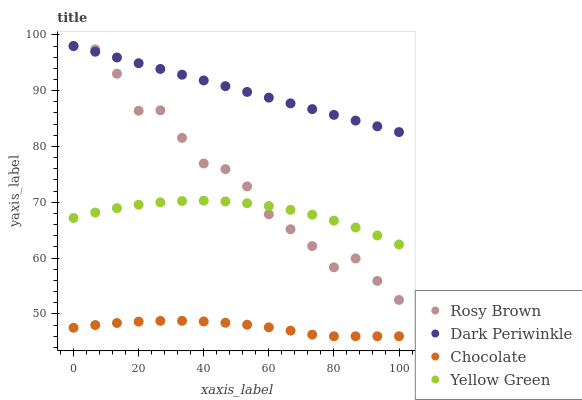Does Chocolate have the minimum area under the curve?
Answer yes or no. Yes. Does Dark Periwinkle have the maximum area under the curve?
Answer yes or no. Yes. Does Rosy Brown have the minimum area under the curve?
Answer yes or no. No. Does Rosy Brown have the maximum area under the curve?
Answer yes or no. No. Is Dark Periwinkle the smoothest?
Answer yes or no. Yes. Is Rosy Brown the roughest?
Answer yes or no. Yes. Is Rosy Brown the smoothest?
Answer yes or no. No. Is Dark Periwinkle the roughest?
Answer yes or no. No. Does Chocolate have the lowest value?
Answer yes or no. Yes. Does Rosy Brown have the lowest value?
Answer yes or no. No. Does Dark Periwinkle have the highest value?
Answer yes or no. Yes. Does Chocolate have the highest value?
Answer yes or no. No. Is Chocolate less than Yellow Green?
Answer yes or no. Yes. Is Dark Periwinkle greater than Chocolate?
Answer yes or no. Yes. Does Yellow Green intersect Rosy Brown?
Answer yes or no. Yes. Is Yellow Green less than Rosy Brown?
Answer yes or no. No. Is Yellow Green greater than Rosy Brown?
Answer yes or no. No. Does Chocolate intersect Yellow Green?
Answer yes or no. No. 